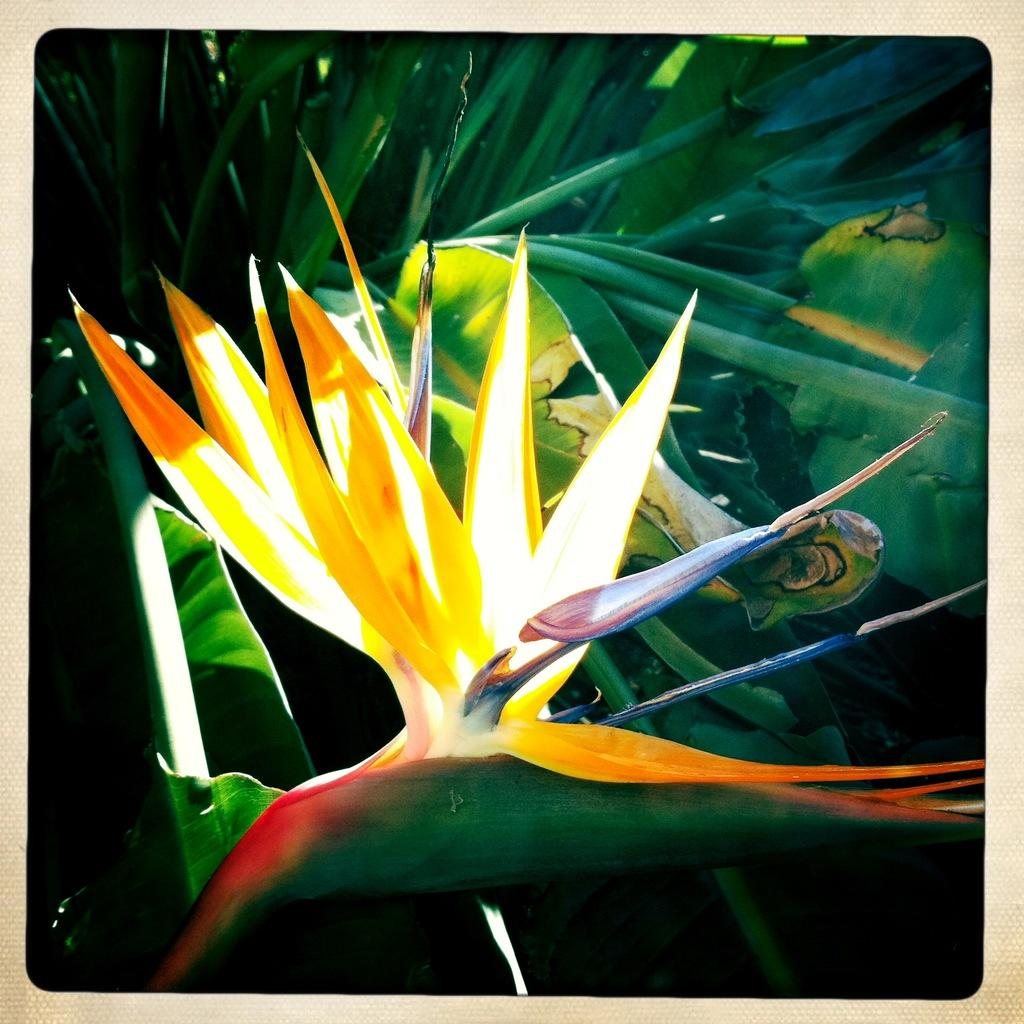What type of living organisms can be seen in the image? Plants can be seen in the image. How many boats are visible in the image? There are no boats present in the image; it only contains plants. Can you describe the tiger's stripes in the image? There is no tiger present in the image, so it is not possible to describe its stripes. 